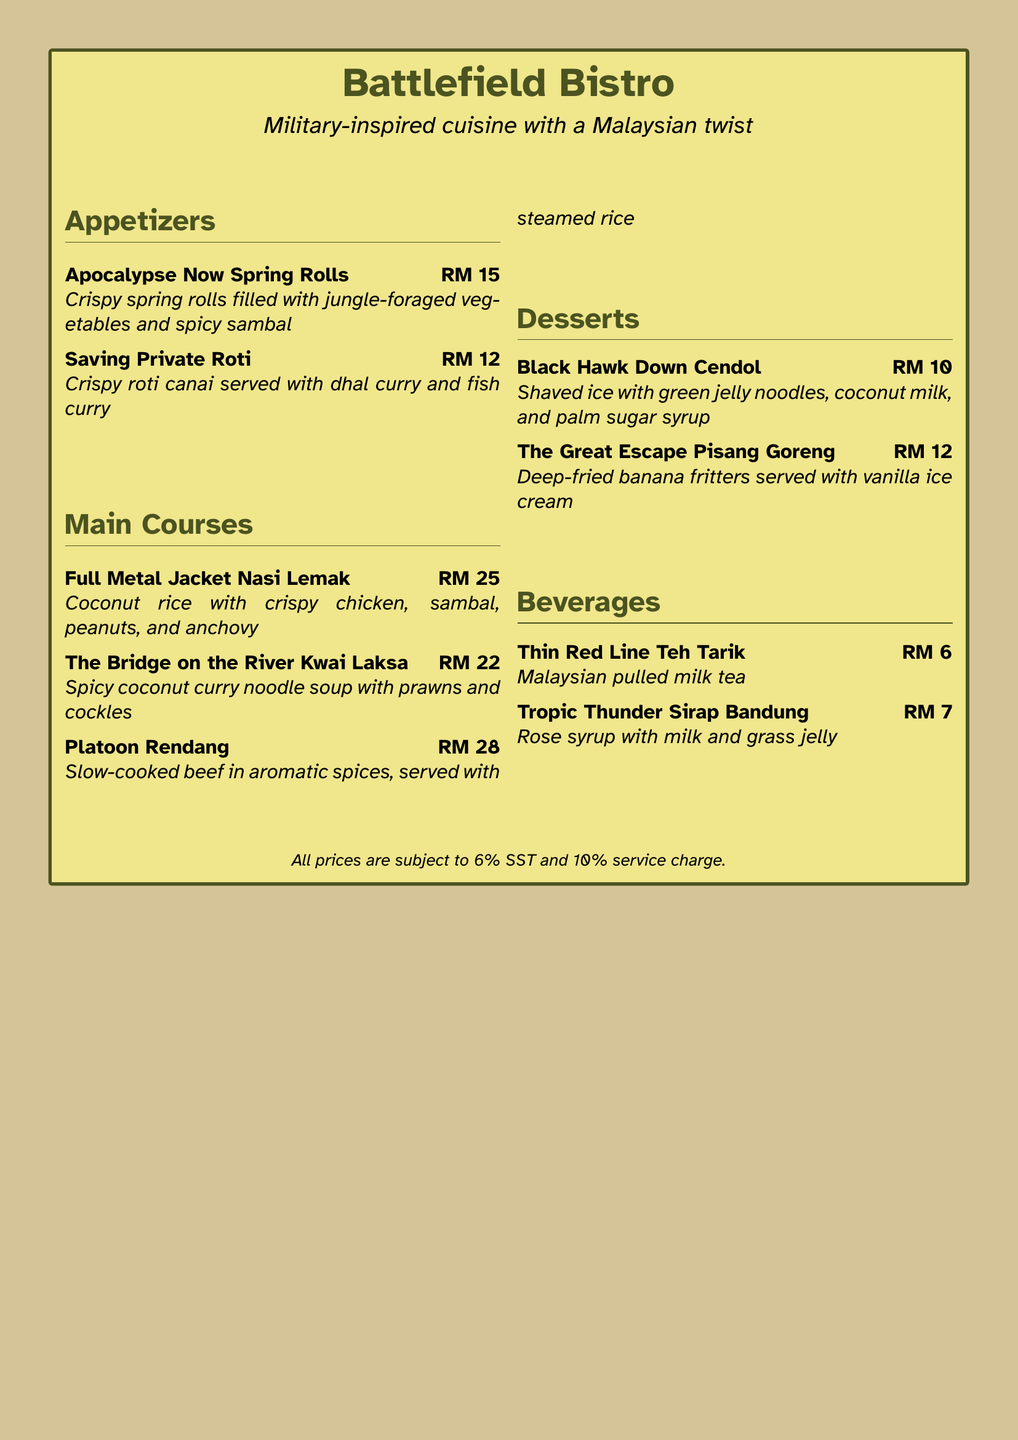What is the name of the bistro? The name of the bistro is prominently stated at the top of the menu.
Answer: Battlefield Bistro What is the price of the "Full Metal Jacket Nasi Lemak"? The price can be found next to the dish's description.
Answer: RM 25 What type of dessert is "Black Hawk Down Cendol"? The dessert can be categorized based on its description in the menu.
Answer: Shaved ice How many appetizers are listed in the menu? The total number of appetizers can be counted from the menu section.
Answer: 2 Which beverage features rose syrup? The menu specifically names a beverage with rose syrup in its title.
Answer: Tropic Thunder Sirap Bandung What is the main ingredient of "Platoon Rendang"? The main ingredient can be inferred from the dish's description in the menu.
Answer: Beef What is included in the "Saving Private Roti" dish? The ingredients are detailed in the menu alongside the dish name.
Answer: Roti canai, dhal curry, fish curry What color scheme is used in the menu layout? The color scheme can be determined from the general aesthetics described.
Answer: Camouflage-themed What dessert is served with vanilla ice cream? The specific dessert can be identified from its description.
Answer: The Great Escape Pisang Goreng 